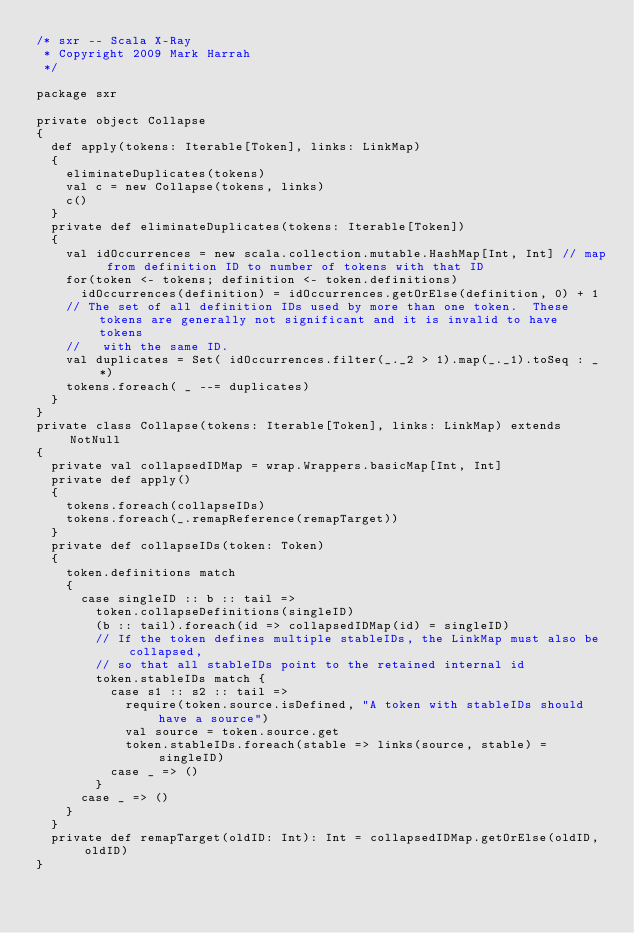Convert code to text. <code><loc_0><loc_0><loc_500><loc_500><_Scala_>/* sxr -- Scala X-Ray
 * Copyright 2009 Mark Harrah
 */

package sxr

private object Collapse
{
  def apply(tokens: Iterable[Token], links: LinkMap)
  {
    eliminateDuplicates(tokens)
    val c = new Collapse(tokens, links)
    c()
  }
  private def eliminateDuplicates(tokens: Iterable[Token])
  {
    val idOccurrences = new scala.collection.mutable.HashMap[Int, Int] // map from definition ID to number of tokens with that ID
    for(token <- tokens; definition <- token.definitions)
      idOccurrences(definition) = idOccurrences.getOrElse(definition, 0) + 1
    // The set of all definition IDs used by more than one token.  These tokens are generally not significant and it is invalid to have tokens
    //   with the same ID.
    val duplicates = Set( idOccurrences.filter(_._2 > 1).map(_._1).toSeq : _*)
    tokens.foreach( _ --= duplicates)
  }
}
private class Collapse(tokens: Iterable[Token], links: LinkMap) extends NotNull
{
  private val collapsedIDMap = wrap.Wrappers.basicMap[Int, Int]
  private def apply()
  {
    tokens.foreach(collapseIDs)
    tokens.foreach(_.remapReference(remapTarget))
  }
  private def collapseIDs(token: Token)
  {
    token.definitions match
    {
      case singleID :: b :: tail =>
        token.collapseDefinitions(singleID)
        (b :: tail).foreach(id => collapsedIDMap(id) = singleID)
        // If the token defines multiple stableIDs, the LinkMap must also be collapsed,
        // so that all stableIDs point to the retained internal id
        token.stableIDs match {
          case s1 :: s2 :: tail =>
            require(token.source.isDefined, "A token with stableIDs should have a source")
            val source = token.source.get
            token.stableIDs.foreach(stable => links(source, stable) = singleID)
          case _ => ()
        }
      case _ => ()
    }
  }
  private def remapTarget(oldID: Int): Int = collapsedIDMap.getOrElse(oldID, oldID)
}
</code> 